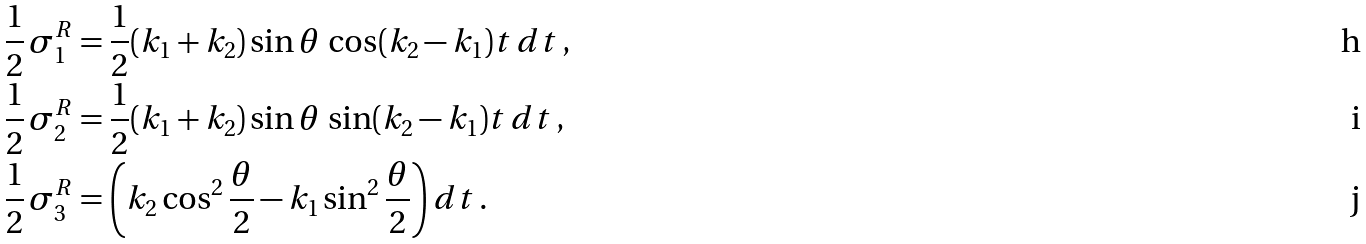<formula> <loc_0><loc_0><loc_500><loc_500>\frac { 1 } { 2 } \, \sigma _ { 1 } ^ { R } & = \frac { 1 } { 2 } ( k _ { 1 } + k _ { 2 } ) \sin \theta \, \cos ( k _ { 2 } - k _ { 1 } ) t \, d t \, , \\ \frac { 1 } { 2 } \, \sigma _ { 2 } ^ { R } & = \frac { 1 } { 2 } ( k _ { 1 } + k _ { 2 } ) \sin \theta \, \sin ( k _ { 2 } - k _ { 1 } ) t \, d t \, , \\ \frac { 1 } { 2 } \, \sigma _ { 3 } ^ { R } & = \left ( k _ { 2 } \cos ^ { 2 } \frac { \theta } { 2 } - k _ { 1 } \sin ^ { 2 } \frac { \theta } { 2 } \right ) d t \, .</formula> 